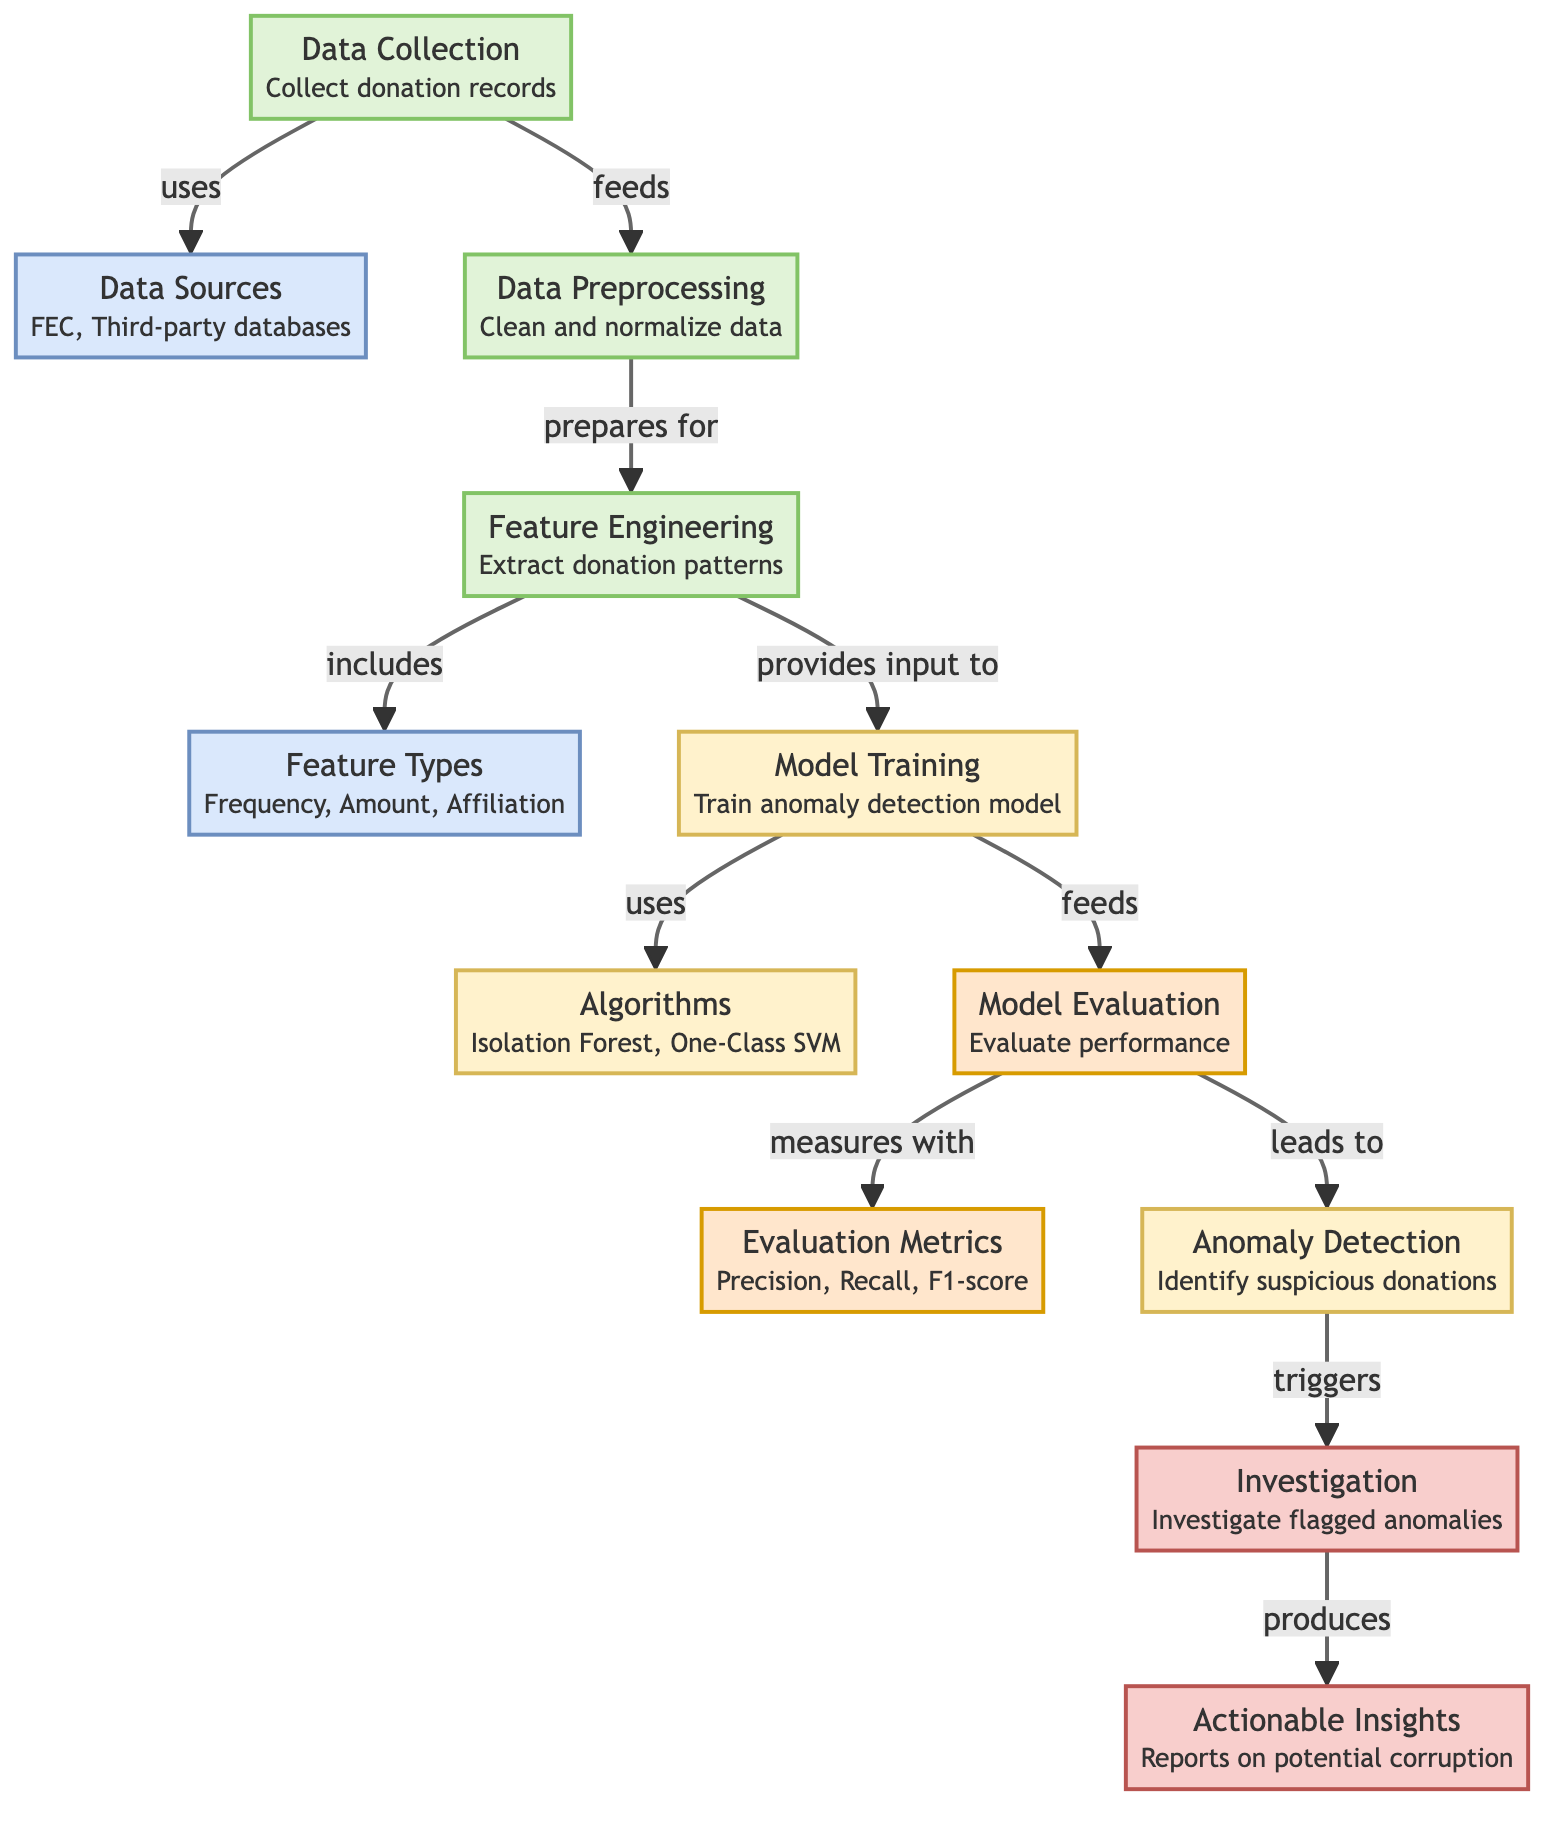What is the first process in this diagram? The diagram starts with the "Data Collection" node, indicating that the first step in the process is to collect donation records.
Answer: Data Collection How many data sources are listed in the diagram? There are two data sources mentioned in the diagram: "FEC" and "Third-party databases," which represent the sources of the collected data.
Answer: Two What type of model is trained in this diagram? The diagram indicates that an "anomaly detection model" is trained, focusing on identifying unusual patterns in the data.
Answer: Anomaly detection model What does the model evaluation measure? The "Model Evaluation" node specifies that the performance of the model is evaluated using "Precision, Recall, F1-score," which are common metrics for evaluating model performance.
Answer: Precision, Recall, F1-score Which node triggers further investigation? The "Anomaly Detection" node triggers the "Investigation" node, suggesting that identifying suspicious donations leads to an investigation into those anomalies.
Answer: Investigation What does the feature engineering process extract? The "Feature Engineering" node highlights that it extracts "donation patterns" from the preprocessed data to prepare it for model training, focusing on relevant characteristics of the donations.
Answer: Donation patterns Which algorithms are used in model training? The diagram lists "Isolation Forest" and "One-Class SVM" as the algorithms utilized for training the anomaly detection model.
Answer: Isolation Forest, One-Class SVM What do actionable insights produce? The "Investigation" node leads to "Actionable Insights," which are reports that provide information on potential corruption, suggesting how the findings can be utilized.
Answer: Reports on potential corruption How does data preprocessing relate to feature engineering? The "data preprocessing" node feeds into the "feature engineering" node, indicating that after data cleaning and normalization, the processed data is prepared for feature extraction.
Answer: Prepares for 